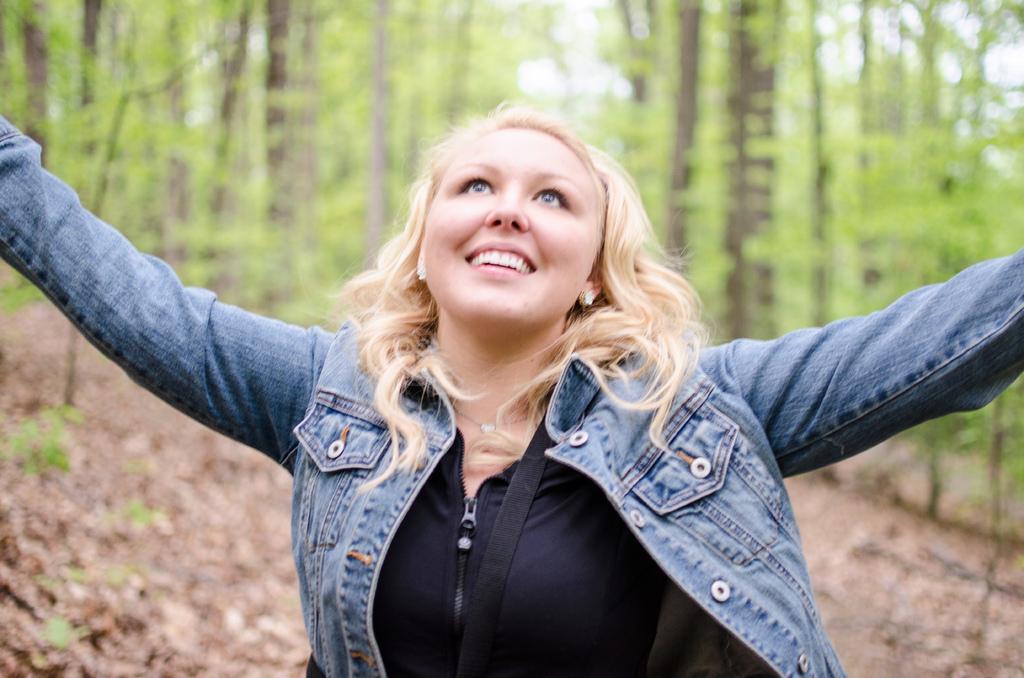In one or two sentences, can you explain what this image depicts? In this image in front there is a person wearing a smile on her smile. In the background of the image there are trees. 